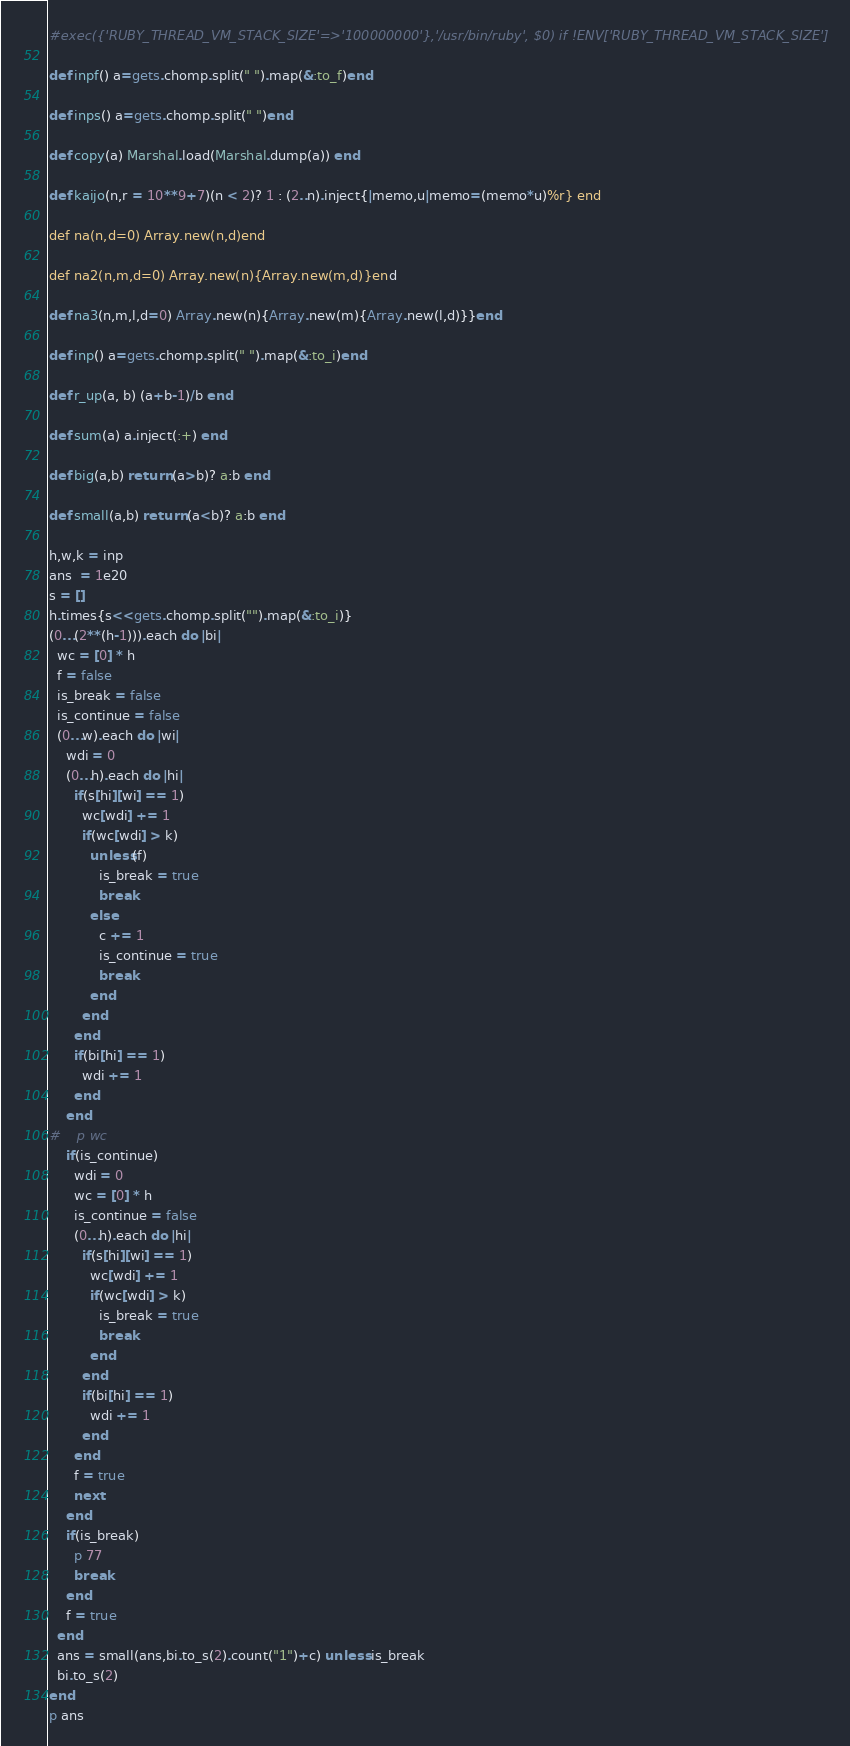Convert code to text. <code><loc_0><loc_0><loc_500><loc_500><_Ruby_>#exec({'RUBY_THREAD_VM_STACK_SIZE'=>'100000000'},'/usr/bin/ruby', $0) if !ENV['RUBY_THREAD_VM_STACK_SIZE']

def inpf() a=gets.chomp.split(" ").map(&:to_f)end

def inps() a=gets.chomp.split(" ")end

def copy(a) Marshal.load(Marshal.dump(a)) end

def kaijo(n,r = 10**9+7)(n < 2)? 1 : (2..n).inject{|memo,u|memo=(memo*u)%r} end

def na(n,d=0) Array.new(n,d)end

def na2(n,m,d=0) Array.new(n){Array.new(m,d)}end

def na3(n,m,l,d=0) Array.new(n){Array.new(m){Array.new(l,d)}}end

def inp() a=gets.chomp.split(" ").map(&:to_i)end

def r_up(a, b) (a+b-1)/b end

def sum(a) a.inject(:+) end

def big(a,b) return (a>b)? a:b end

def small(a,b) return (a<b)? a:b end

h,w,k = inp
ans  = 1e20
s = []
h.times{s<<gets.chomp.split("").map(&:to_i)}
(0...(2**(h-1))).each do |bi|
  wc = [0] * h
  f = false
  is_break = false
  is_continue = false
  (0...w).each do |wi|
    wdi = 0
    (0...h).each do |hi|
      if(s[hi][wi] == 1)
        wc[wdi] += 1
        if(wc[wdi] > k)
          unless(f)
            is_break = true
            break
          else
            c += 1
            is_continue = true
            break
          end
        end
      end
      if(bi[hi] == 1)
        wdi += 1
      end
    end
#    p wc
    if(is_continue)
      wdi = 0
      wc = [0] * h
      is_continue = false
      (0...h).each do |hi|
        if(s[hi][wi] == 1)
          wc[wdi] += 1
          if(wc[wdi] > k)
            is_break = true
            break
          end
        end
        if(bi[hi] == 1)
          wdi += 1
        end
      end
      f = true
      next
    end
    if(is_break)
      p 77
      break
    end
    f = true
  end
  ans = small(ans,bi.to_s(2).count("1")+c) unless is_break
  bi.to_s(2)
end
p ans
</code> 